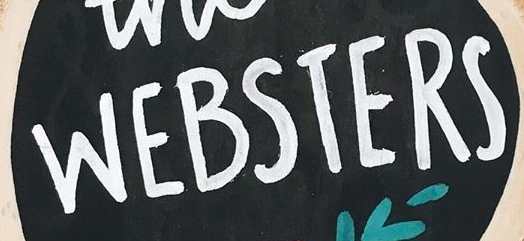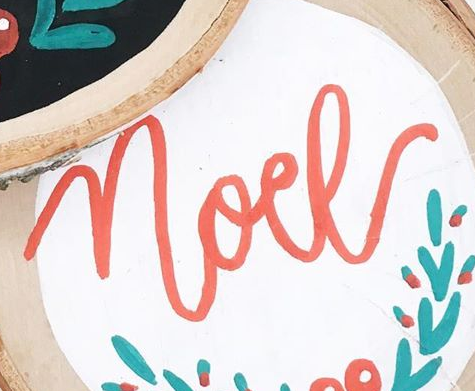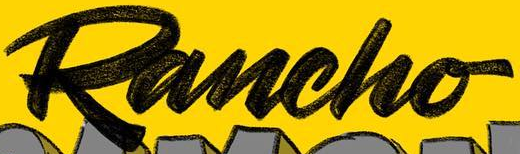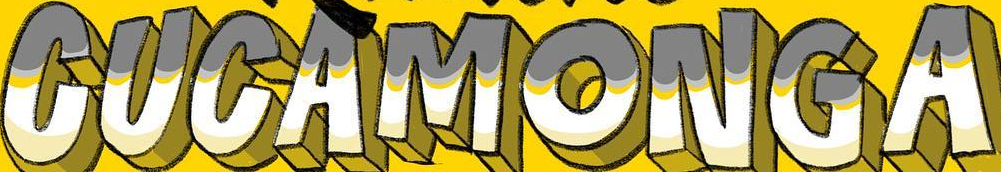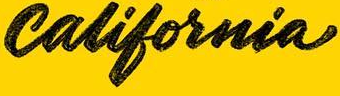Identify the words shown in these images in order, separated by a semicolon. WEBSTERS; noel; Rancho; CUCAMONGA; california 